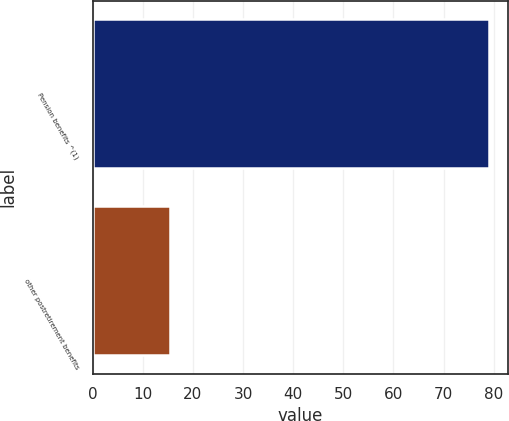<chart> <loc_0><loc_0><loc_500><loc_500><bar_chart><fcel>Pension benefits ^(1)<fcel>other postretirement benefits<nl><fcel>79<fcel>15.4<nl></chart> 